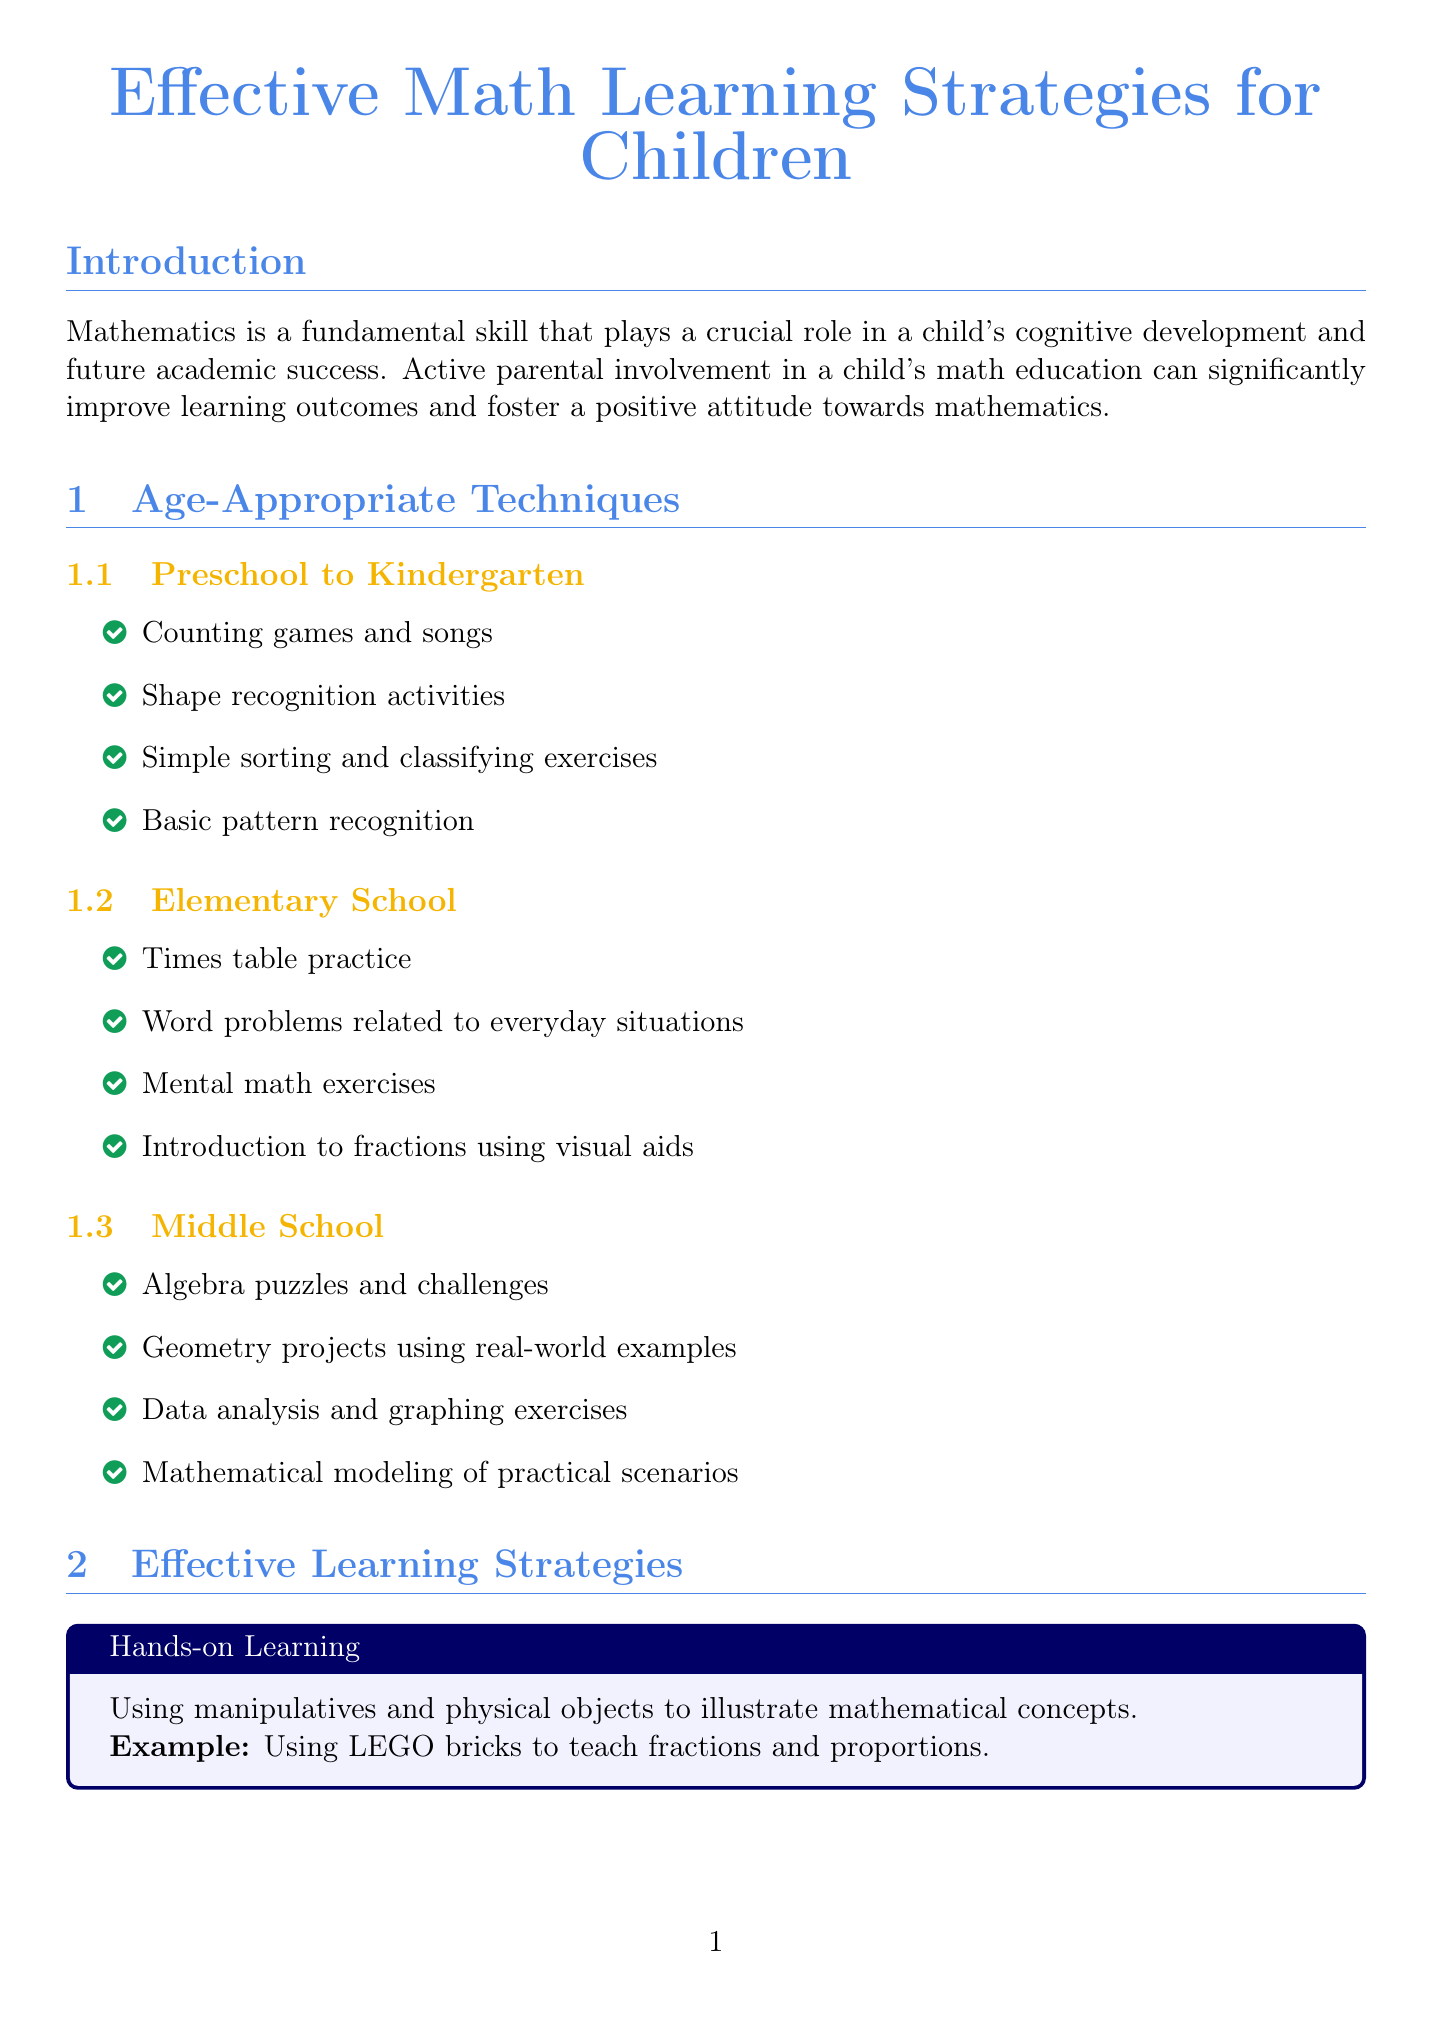What is the title of a recommended book for ages 3-8? The document lists "Bedtime Math: A Fun Excuse to Stay Up Late" as a recommended book for ages 3-8.
Answer: Bedtime Math: A Fun Excuse to Stay Up Late What is a technique for preschool to kindergarten children? The document mentions "Counting games and songs" as a technique for preschool to kindergarten children.
Answer: Counting games and songs What is one effective learning strategy mentioned in the report? The document lists "Hands-on learning" as one of the effective learning strategies.
Answer: Hands-on learning What age range is the educational app "Photomath" designed for? The document specifies that "Photomath" is designed for ages 12 and up.
Answer: 12+ What is a sign of math anxiety according to the document? The document states that "Avoidance of math-related activities" is a sign of math anxiety.
Answer: Avoidance of math-related activities What parental involvement tip is suggested in the report? The document recommends to "Set aside dedicated math practice time" as a parental involvement tip.
Answer: Set aside dedicated math practice time What online platform is mentioned for free courses? The document lists "Khan Academy" as an online platform offering free courses.
Answer: Khan Academy What is one reason why mathematics is important for children? The document states that mathematics plays a crucial role in a child's cognitive development.
Answer: Cognitive development 